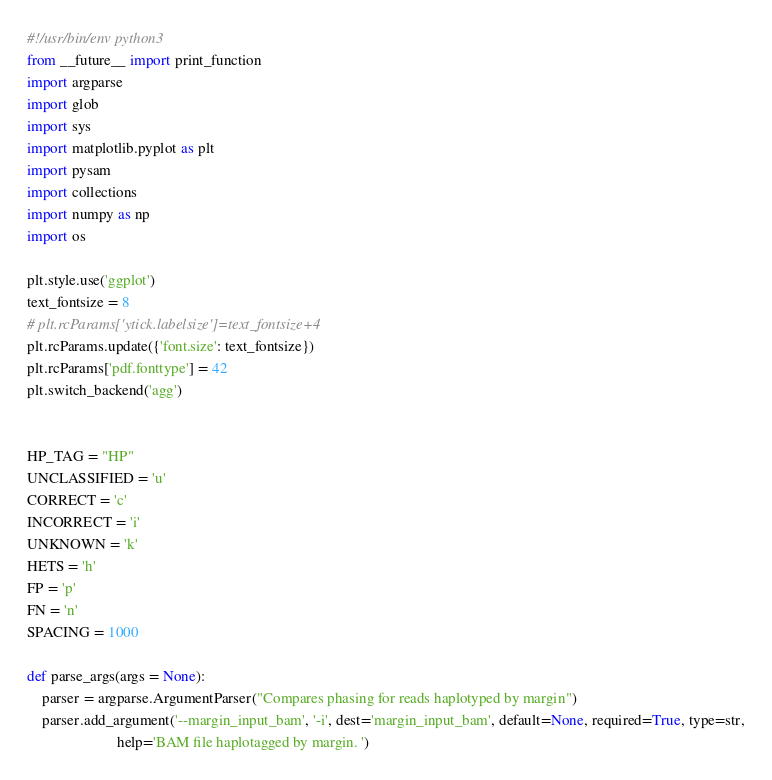<code> <loc_0><loc_0><loc_500><loc_500><_Python_>#!/usr/bin/env python3
from __future__ import print_function
import argparse
import glob
import sys
import matplotlib.pyplot as plt
import pysam
import collections
import numpy as np
import os

plt.style.use('ggplot')
text_fontsize = 8
# plt.rcParams['ytick.labelsize']=text_fontsize+4
plt.rcParams.update({'font.size': text_fontsize})
plt.rcParams['pdf.fonttype'] = 42
plt.switch_backend('agg')


HP_TAG = "HP"
UNCLASSIFIED = 'u'
CORRECT = 'c'
INCORRECT = 'i'
UNKNOWN = 'k'
HETS = 'h'
FP = 'p'
FN = 'n'
SPACING = 1000

def parse_args(args = None):
    parser = argparse.ArgumentParser("Compares phasing for reads haplotyped by margin")
    parser.add_argument('--margin_input_bam', '-i', dest='margin_input_bam', default=None, required=True, type=str,
                        help='BAM file haplotagged by margin. ')</code> 